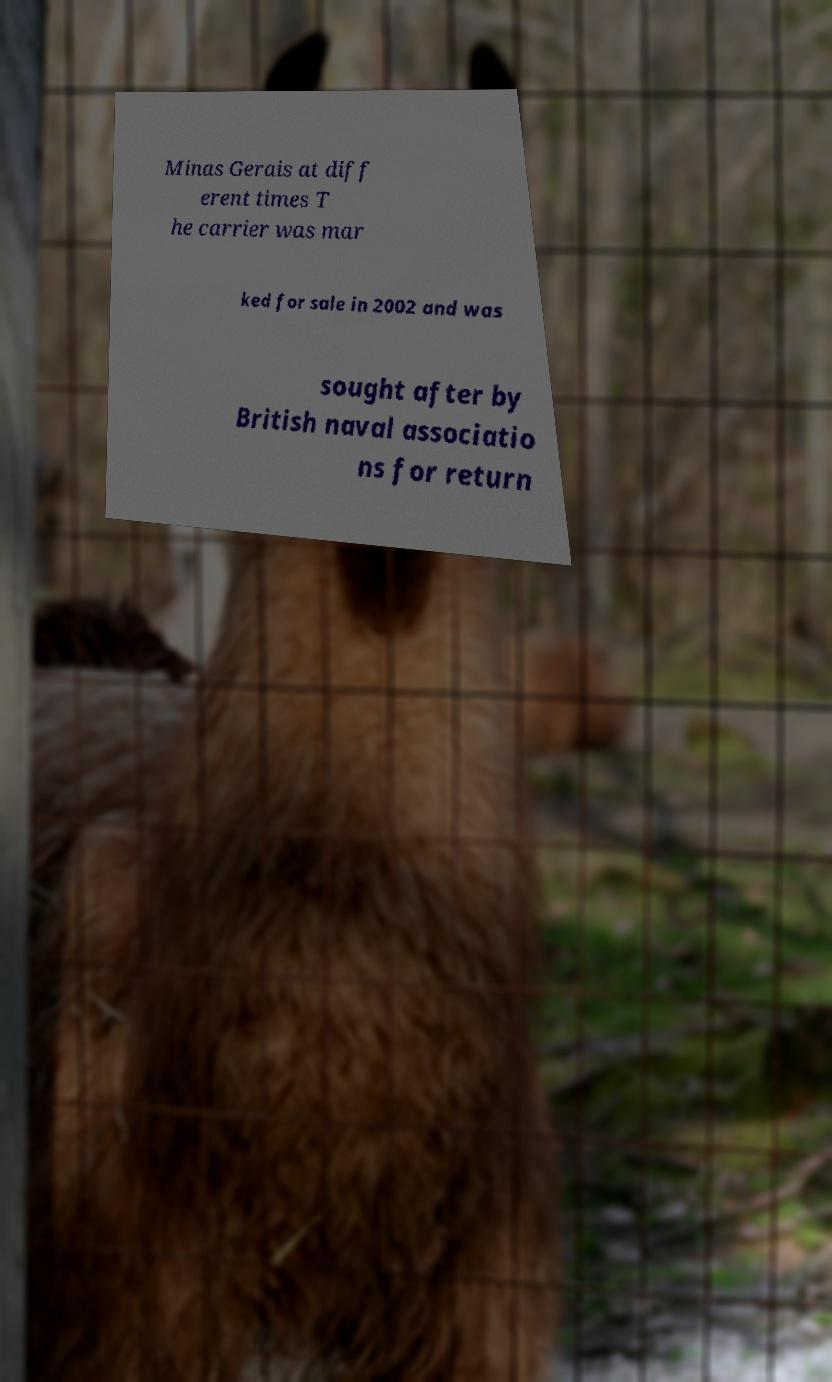Could you extract and type out the text from this image? Minas Gerais at diff erent times T he carrier was mar ked for sale in 2002 and was sought after by British naval associatio ns for return 